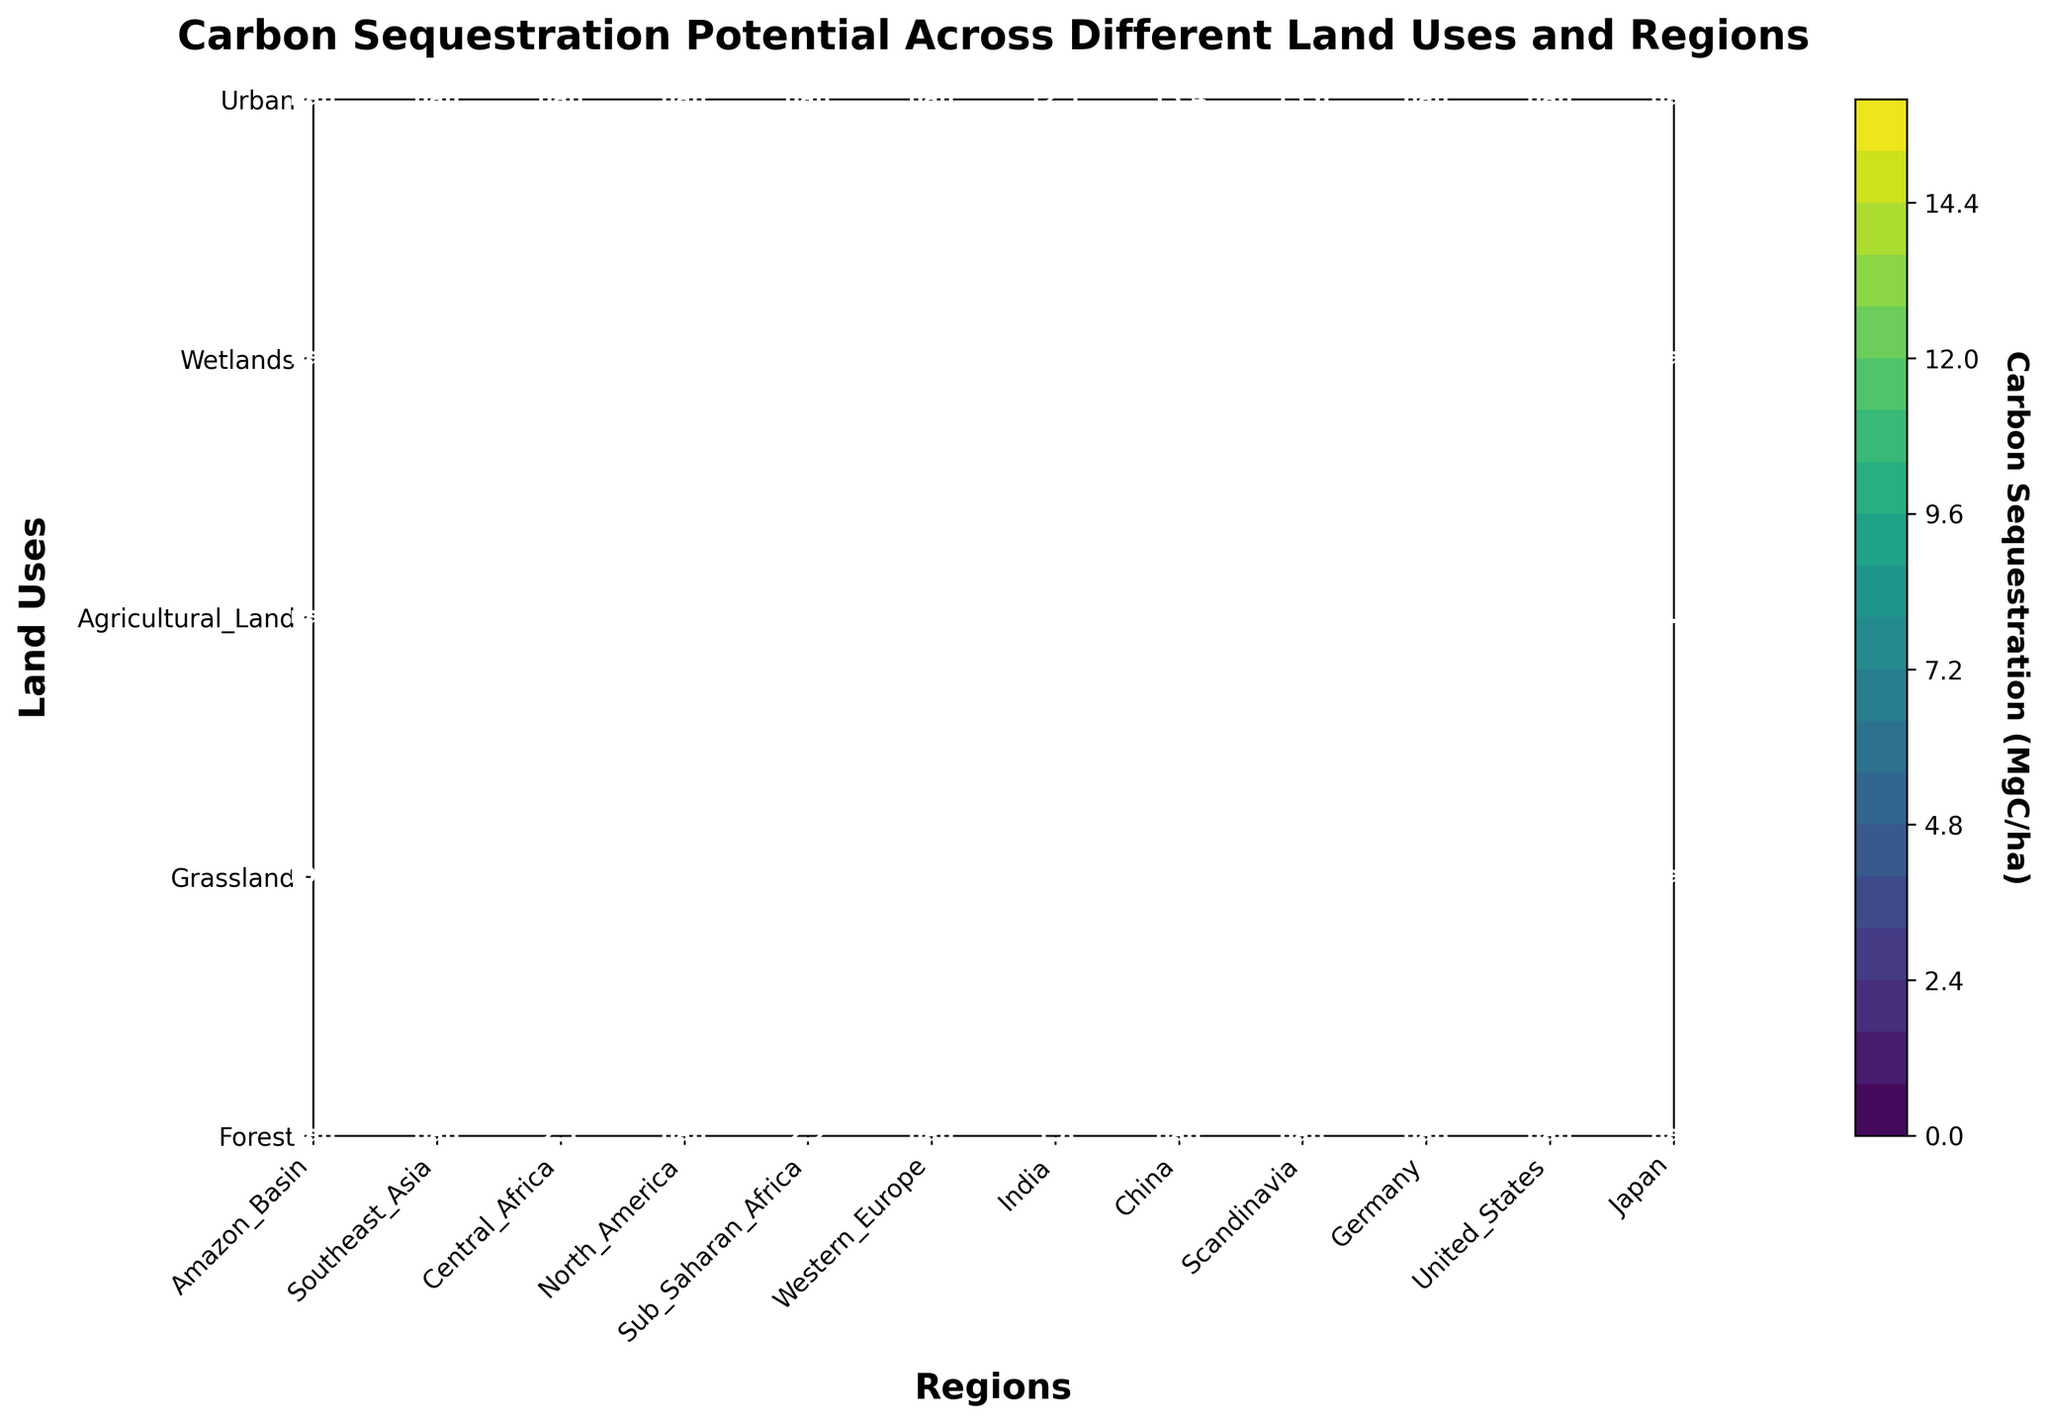what is the highest carbon sequestration value for wetlands? Locate the row for "Wetlands" on the y-axis and identify the maximum value in that row. The values for "Wetlands" are 15.6, 12.1, and 13.4. The highest of these values is 15.6 (in Southeast Asia).
Answer: 15.6 MgC/ha Which land use has the lowest carbon sequestration value overall? Examine all values in the contour plot and identify the lowest one. The lowest value is 0.3 (for Urban land use in the United States).
Answer: Urban What is the difference in carbon sequestration between forests in the Amazon Basin and Southeast Asia? Locate "Forest" on the y-axis and find the values for the Amazon Basin (10.2) and Southeast Asia (7.8). Subtract the smaller value from the larger: 10.2 - 7.8 = 2.4.
Answer: 2.4 MgC/ha Which region has the highest variation in carbon sequestration values across different land uses? Compare the range (difference between maximum and minimum values) of carbon sequestration for each region by analyzing the values per region. Southeast Asia has 15.6 (Wetlands) and 7.8 (Forest), so the variation is 15.6 - 7.8 = 7.8.
Answer: Southeast Asia How does carbon sequestration in agricultural land in India compare to that in China? Locate "Agricultural Land" on the y-axis and find the values for India (2.2) and China (2.1). India has a value of 2.2, which is slightly higher than China’s 2.1.
Answer: India is higher What is the average carbon sequestration potential for grasslands? Locate "Grassland" on the y-axis and find the values: 4.3 (North America), 2.9 (Sub-Saharan Africa), and 3.5 (Western Europe). Sum these values and divide by the number of data points: (4.3 + 2.9 + 3.5)/3 = 10.7/3 ≈ 3.57.
Answer: 3.57 MgC/ha What is the median carbon sequestration value for forests across the three regions? Identify the values for "Forest": 10.2 (Amazon Basin), 7.8 (Southeast Asia), and 9.5 (Central Africa). Arrange these in numerical order: 7.8, 9.5, 10.2. The median value, being the middle value, is 9.5.
Answer: 9.5 MgC/ha What is the ratio of carbon sequestration between wetlands in Southeast Asia and urban areas in Germany? Locate the values: 15.6 for Wetlands in Southeast Asia and 0.5 for Urban areas in Germany. Calculate the ratio: 15.6 / 0.5 = 31.2.
Answer: 31.2 Which region has higher carbon sequestration potential on average: North America or Scandinavia? Compute the average for North America by summing values and dividing by the number of land uses: (4.3 + 12.1 + 1.8)/3 ≈ 6.07. For Scandinavia, the only value is 13.4 (Wetlands). Comparing these averages, Scandinavia has a higher average.
Answer: Scandinavia 